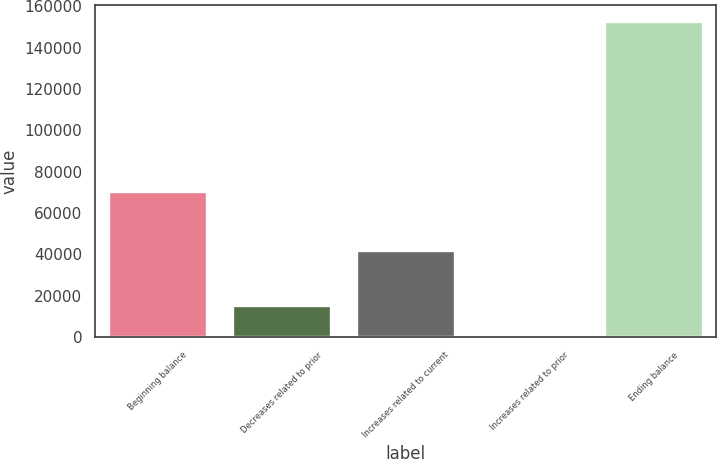Convert chart to OTSL. <chart><loc_0><loc_0><loc_500><loc_500><bar_chart><fcel>Beginning balance<fcel>Decreases related to prior<fcel>Increases related to current<fcel>Increases related to prior<fcel>Ending balance<nl><fcel>70490<fcel>15423.1<fcel>42328<fcel>154<fcel>152845<nl></chart> 